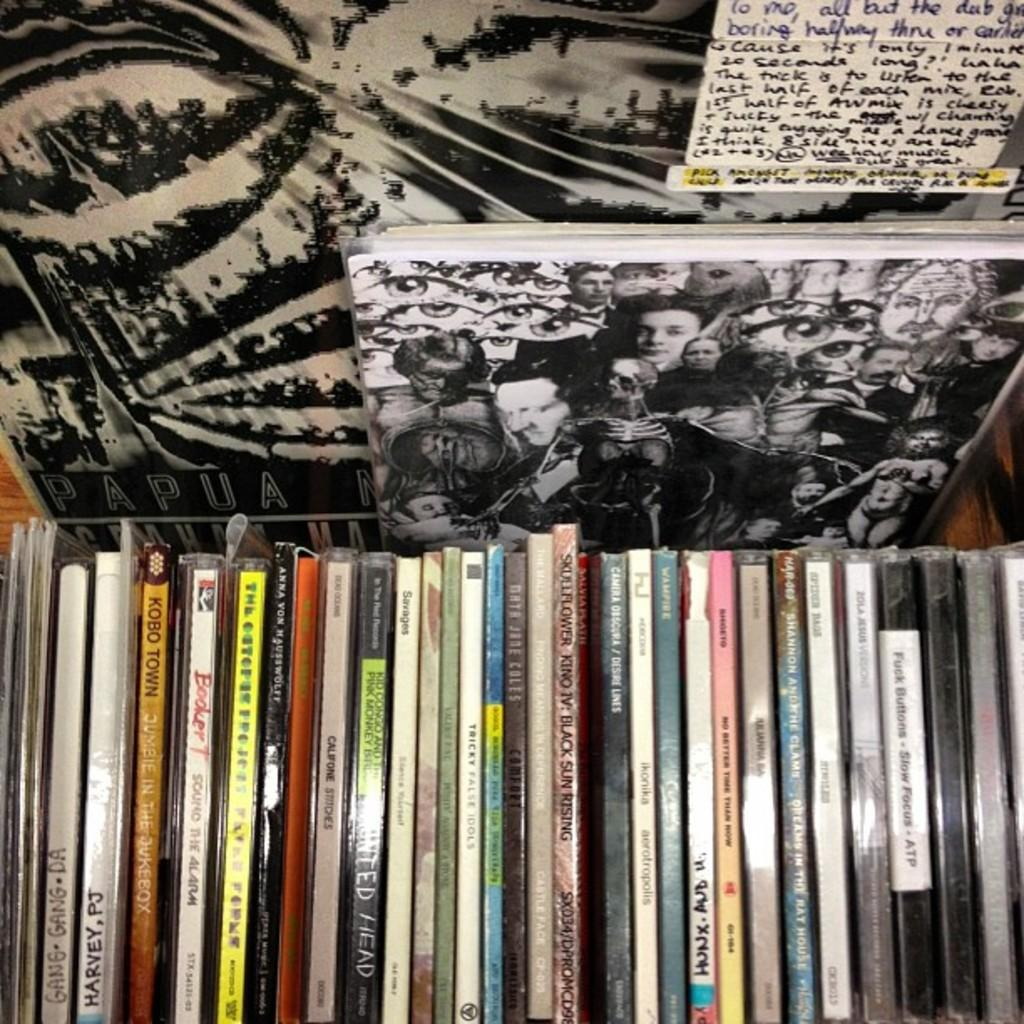<image>
Give a short and clear explanation of the subsequent image. many cd's one with the word kobo on it 